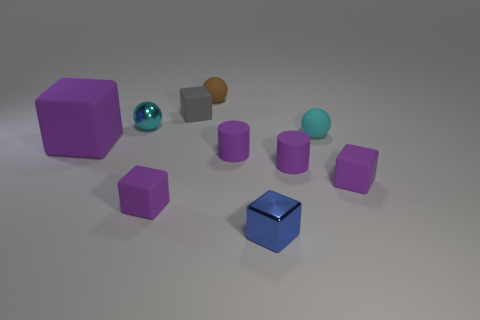How many objects are there in the image, and can you describe them? There are eight objects in the image. Starting from the left, there is a large purple cube, a shiny teal sphere, a small gray cube, a brown sphere, a medium-sized purple cube followed by three smaller purple cubes, and in the foreground a small, blue-tinted cube with a reflective surface. 